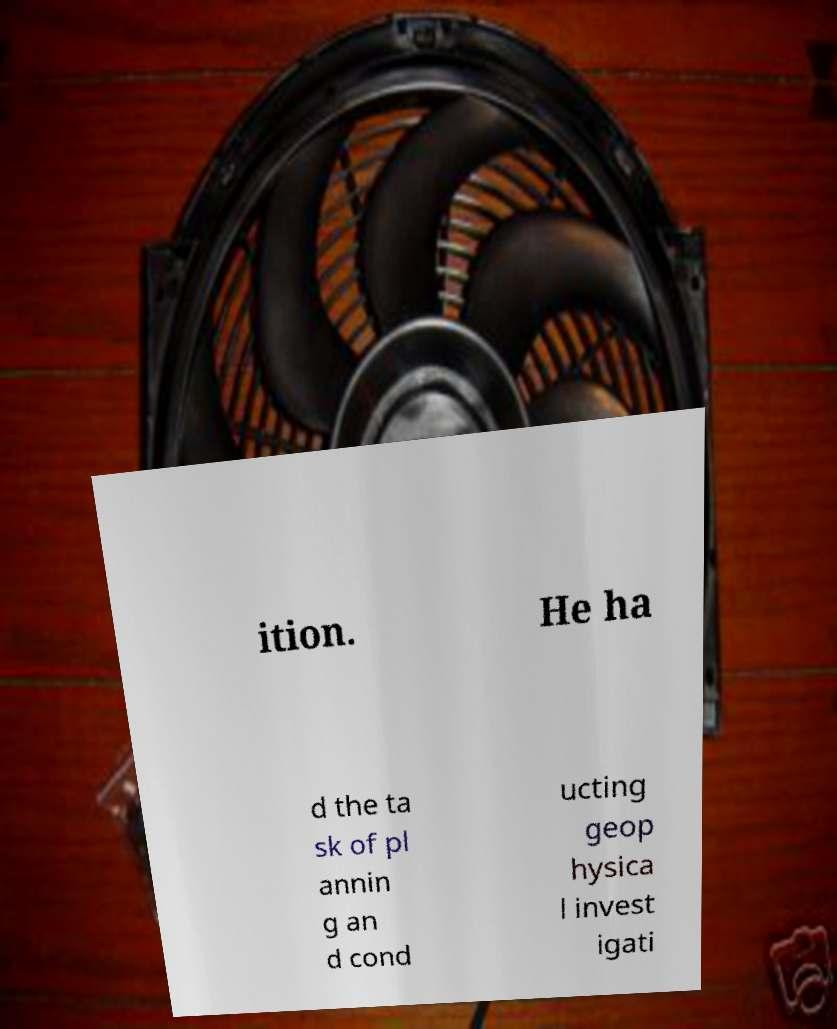I need the written content from this picture converted into text. Can you do that? ition. He ha d the ta sk of pl annin g an d cond ucting geop hysica l invest igati 